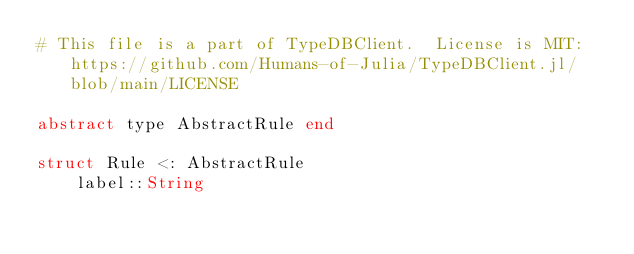<code> <loc_0><loc_0><loc_500><loc_500><_Julia_># This file is a part of TypeDBClient.  License is MIT: https://github.com/Humans-of-Julia/TypeDBClient.jl/blob/main/LICENSE

abstract type AbstractRule end

struct Rule <: AbstractRule
    label::String</code> 